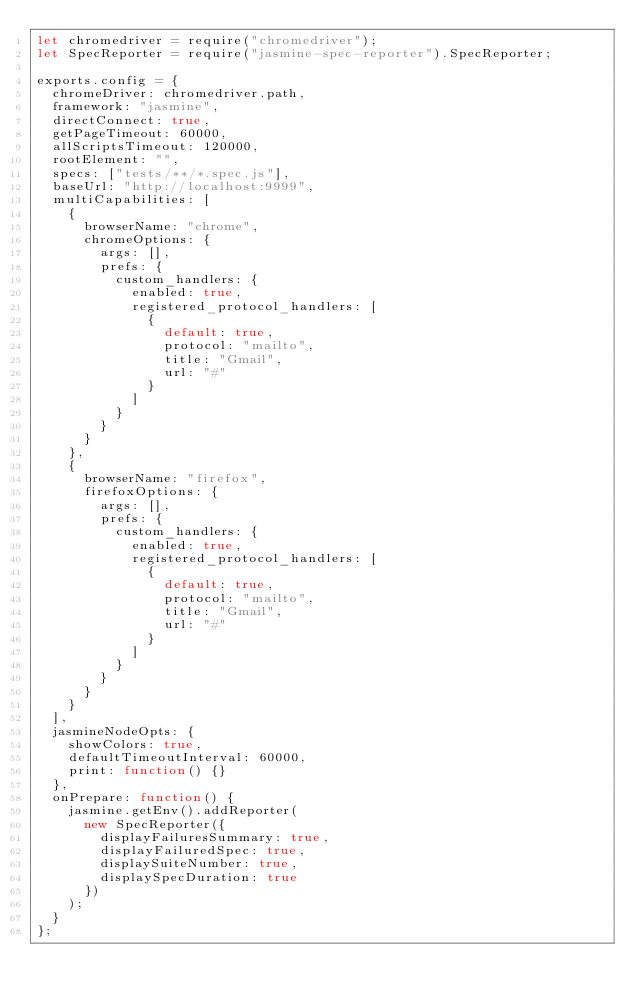Convert code to text. <code><loc_0><loc_0><loc_500><loc_500><_JavaScript_>let chromedriver = require("chromedriver");
let SpecReporter = require("jasmine-spec-reporter").SpecReporter;

exports.config = {
  chromeDriver: chromedriver.path,
  framework: "jasmine",
  directConnect: true,
  getPageTimeout: 60000,
  allScriptsTimeout: 120000,
  rootElement: "",
  specs: ["tests/**/*.spec.js"],
  baseUrl: "http://localhost:9999",
  multiCapabilities: [
    {
      browserName: "chrome",
      chromeOptions: {
        args: [],
        prefs: {
          custom_handlers: {
            enabled: true,
            registered_protocol_handlers: [
              {
                default: true,
                protocol: "mailto",
                title: "Gmail",
                url: "#"
              }
            ]
          }
        }
      }
    },
    {
      browserName: "firefox",
      firefoxOptions: {
        args: [],
        prefs: {
          custom_handlers: {
            enabled: true,
            registered_protocol_handlers: [
              {
                default: true,
                protocol: "mailto",
                title: "Gmail",
                url: "#"
              }
            ]
          }
        }
      }
    }
  ],
  jasmineNodeOpts: {
    showColors: true,
    defaultTimeoutInterval: 60000,
    print: function() {}
  },
  onPrepare: function() {
    jasmine.getEnv().addReporter(
      new SpecReporter({
        displayFailuresSummary: true,
        displayFailuredSpec: true,
        displaySuiteNumber: true,
        displaySpecDuration: true
      })
    );
  }
};
</code> 